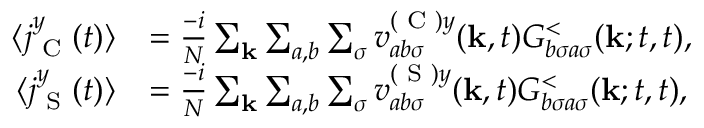<formula> <loc_0><loc_0><loc_500><loc_500>\begin{array} { r l } { \langle j _ { C } ^ { y } ( t ) \rangle } & { = \frac { - i } { N } \sum _ { k } \sum _ { a , b } \sum _ { \sigma } v _ { a b \sigma } ^ { ( C ) y } ( k , t ) G _ { b \sigma a \sigma } ^ { < } ( k ; t , t ) , } \\ { \langle j _ { S } ^ { y } ( t ) \rangle } & { = \frac { - i } { N } \sum _ { k } \sum _ { a , b } \sum _ { \sigma } v _ { a b \sigma } ^ { ( S ) y } ( k , t ) G _ { b \sigma a \sigma } ^ { < } ( k ; t , t ) , } \end{array}</formula> 